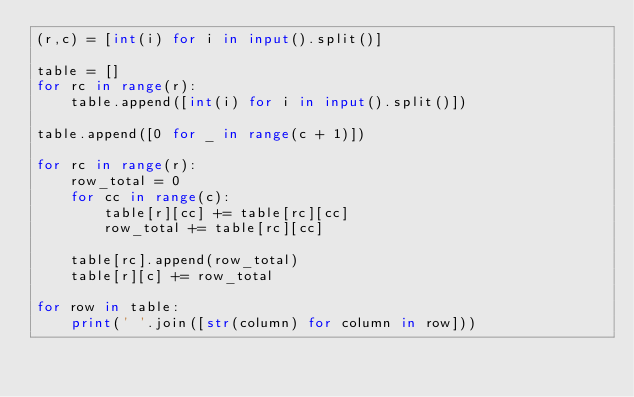<code> <loc_0><loc_0><loc_500><loc_500><_Python_>(r,c) = [int(i) for i in input().split()]

table = []
for rc in range(r):
    table.append([int(i) for i in input().split()])

table.append([0 for _ in range(c + 1)])

for rc in range(r):
    row_total = 0
    for cc in range(c):
        table[r][cc] += table[rc][cc]
        row_total += table[rc][cc]

    table[rc].append(row_total)
    table[r][c] += row_total

for row in table:
    print(' '.join([str(column) for column in row]))</code> 